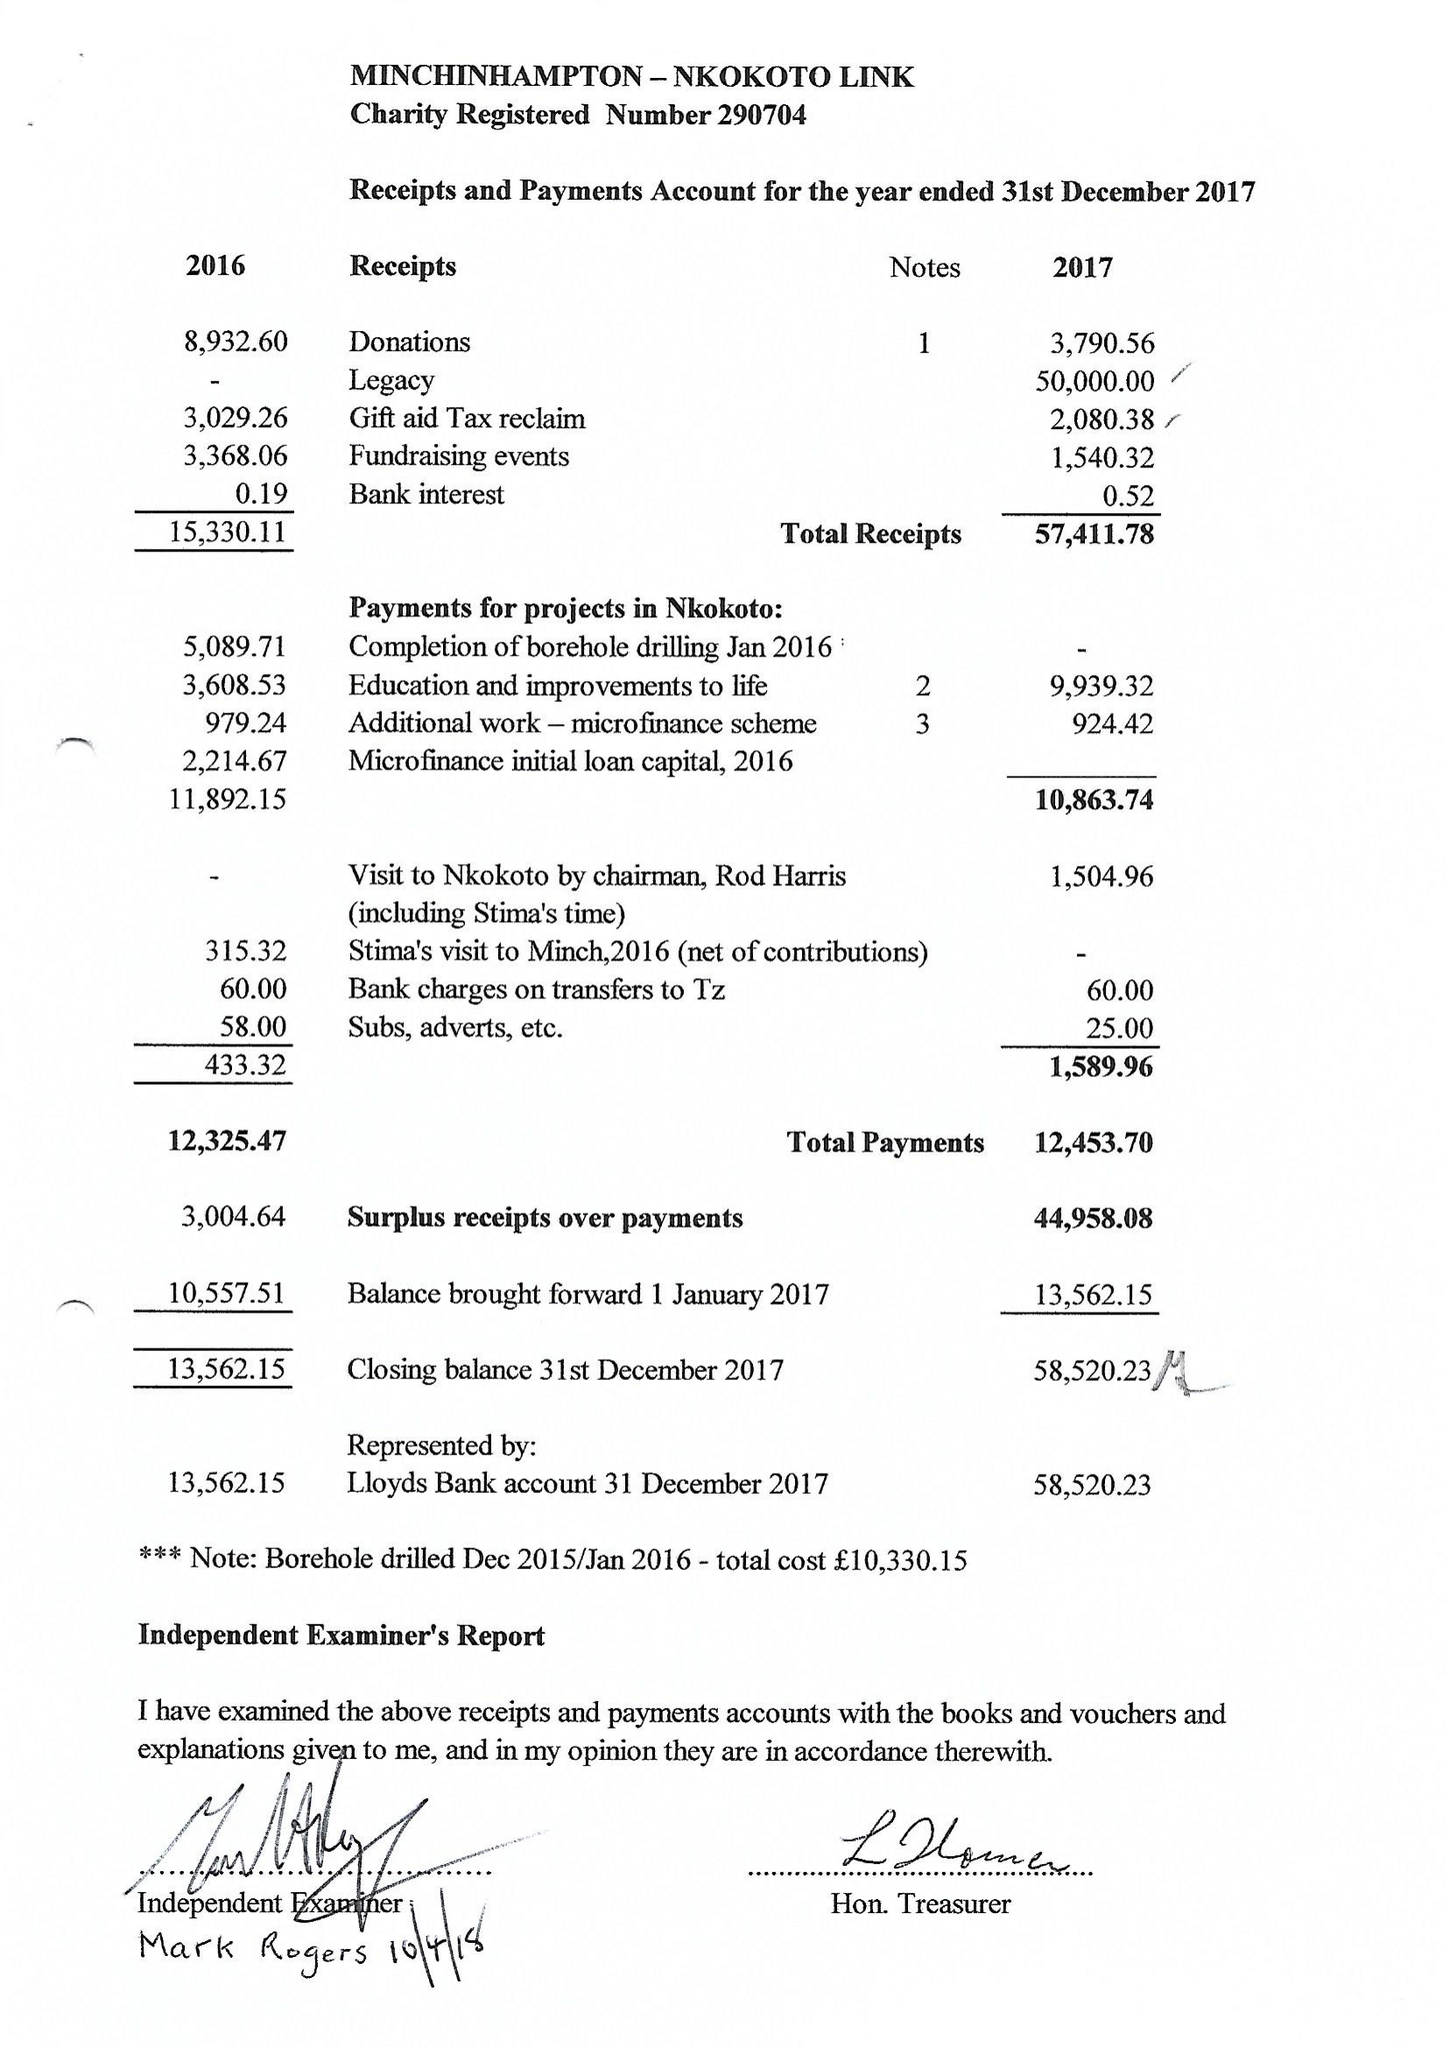What is the value for the address__post_town?
Answer the question using a single word or phrase. STROUD 